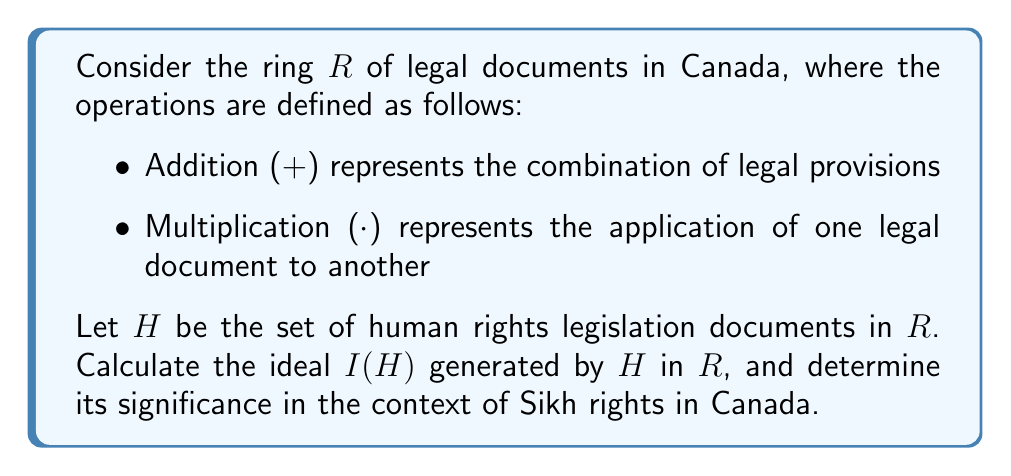Can you answer this question? To solve this problem, we need to follow these steps:

1) Recall that an ideal $I$ in a ring $R$ is a subset of $R$ that satisfies:
   a) $I$ is closed under addition
   b) For any $r \in R$ and $i \in I$, both $ri$ and $ir$ are in $I$

2) The ideal generated by a set $H$, denoted $I(H)$, is the smallest ideal containing $H$. It can be expressed as:

   $$I(H) = \{r_1h_1 + r_2h_2 + ... + r_nh_n | r_i \in R, h_i \in H, n \in \mathbb{N}\}$$

3) In our context:
   - $R$ represents all legal documents in Canada
   - $H$ represents human rights legislation documents
   - $I(H)$ represents all legal documents that can be derived from or are influenced by human rights legislation

4) The significance of $I(H)$ for Sikh rights in Canada:
   a) Any document in $I(H)$ must consider human rights principles
   b) Sikh rights, as part of religious freedom protected by human rights legislation, are implicitly included in every document in $I(H)$
   c) Legal interpretations and applications (represented by multiplication in $R$) of human rights documents to other legal areas will generate new elements in $I(H)$, potentially expanding protections for Sikh rights

5) Examples of elements in $I(H)$:
   - Direct human rights legislation (e.g., Canadian Human Rights Act)
   - Court decisions interpreting human rights legislation
   - Policies and regulations derived from human rights principles
   - Amendments to existing laws to comply with human rights standards

6) The ideal $I(H)$ ensures that human rights considerations, including protections for Sikh rights, permeate throughout the Canadian legal system.
Answer: The ideal $I(H)$ generated by human rights legislation $H$ in the ring $R$ of legal documents is:

$$I(H) = \{r_1h_1 + r_2h_2 + ... + r_nh_n | r_i \in R, h_i \in H, n \in \mathbb{N}\}$$

This ideal represents all legal documents and interpretations influenced by human rights legislation, ensuring that Sikh rights, as protected by human rights laws, are considered and respected throughout the Canadian legal system. 